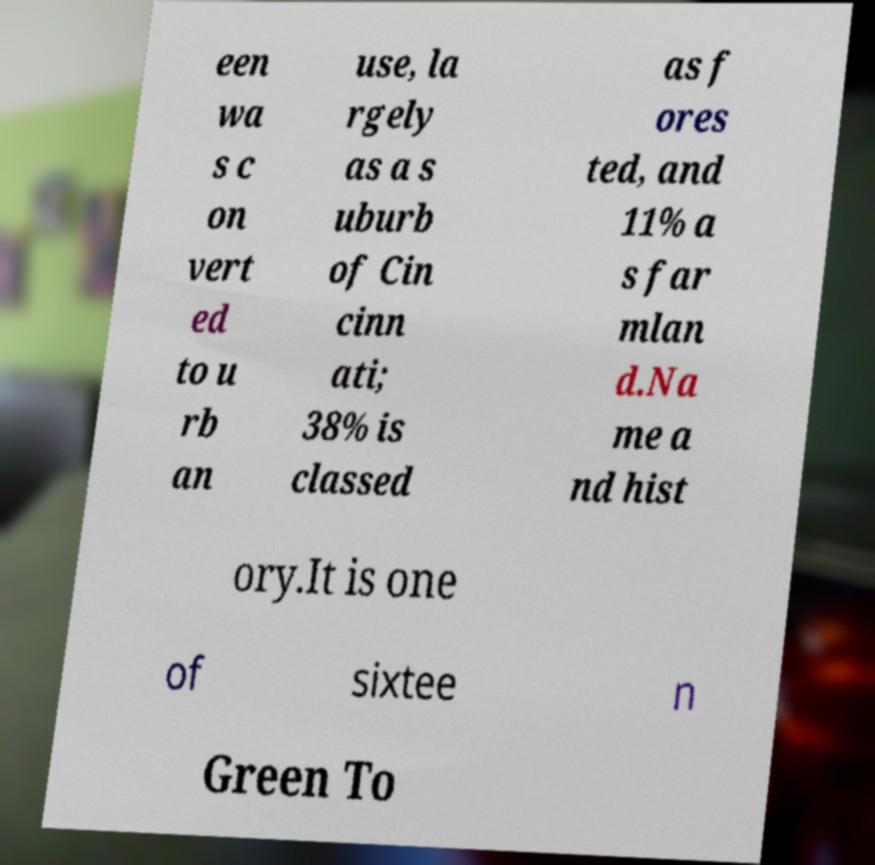For documentation purposes, I need the text within this image transcribed. Could you provide that? een wa s c on vert ed to u rb an use, la rgely as a s uburb of Cin cinn ati; 38% is classed as f ores ted, and 11% a s far mlan d.Na me a nd hist ory.It is one of sixtee n Green To 